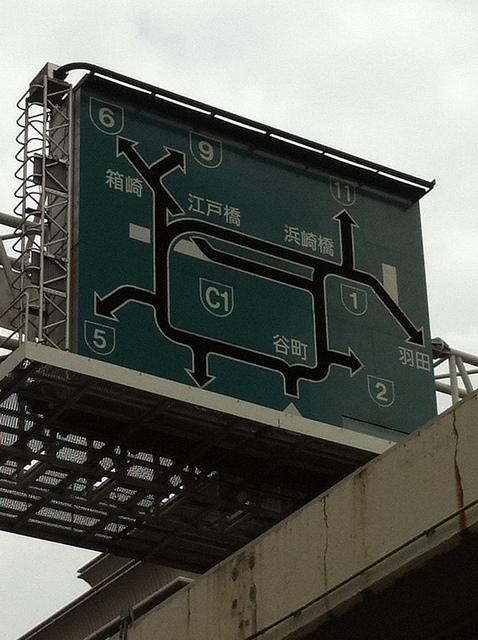What is the sum total of all the numbers shown?
Be succinct. 35. What area of the world is this sign in?
Be succinct. Asia. What is the biggest number on the sign?
Give a very brief answer. 11. 